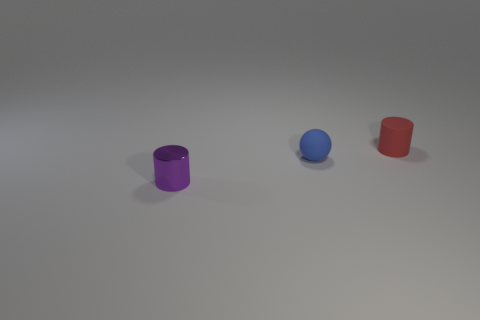Add 1 rubber balls. How many objects exist? 4 Subtract all balls. How many objects are left? 2 Subtract all spheres. Subtract all blue matte objects. How many objects are left? 1 Add 3 red cylinders. How many red cylinders are left? 4 Add 1 small red matte things. How many small red matte things exist? 2 Subtract 0 brown cubes. How many objects are left? 3 